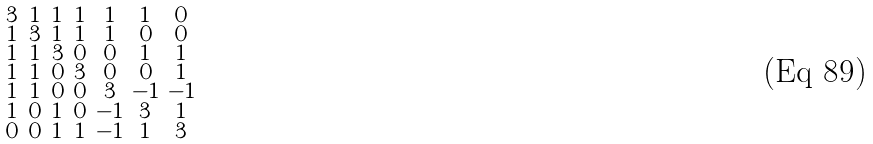Convert formula to latex. <formula><loc_0><loc_0><loc_500><loc_500>\begin{smallmatrix} 3 & 1 & 1 & 1 & 1 & 1 & 0 \\ 1 & 3 & 1 & 1 & 1 & 0 & 0 \\ 1 & 1 & 3 & 0 & 0 & 1 & 1 \\ 1 & 1 & 0 & 3 & 0 & 0 & 1 \\ 1 & 1 & 0 & 0 & 3 & - 1 & - 1 \\ 1 & 0 & 1 & 0 & - 1 & 3 & 1 \\ 0 & 0 & 1 & 1 & - 1 & 1 & 3 \end{smallmatrix}</formula> 